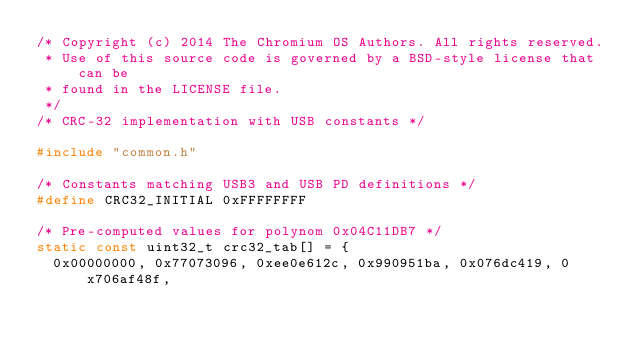Convert code to text. <code><loc_0><loc_0><loc_500><loc_500><_C_>/* Copyright (c) 2014 The Chromium OS Authors. All rights reserved.
 * Use of this source code is governed by a BSD-style license that can be
 * found in the LICENSE file.
 */
/* CRC-32 implementation with USB constants */

#include "common.h"

/* Constants matching USB3 and USB PD definitions */
#define CRC32_INITIAL 0xFFFFFFFF

/* Pre-computed values for polynom 0x04C11DB7 */
static const uint32_t crc32_tab[] = {
	0x00000000, 0x77073096, 0xee0e612c, 0x990951ba, 0x076dc419, 0x706af48f,</code> 